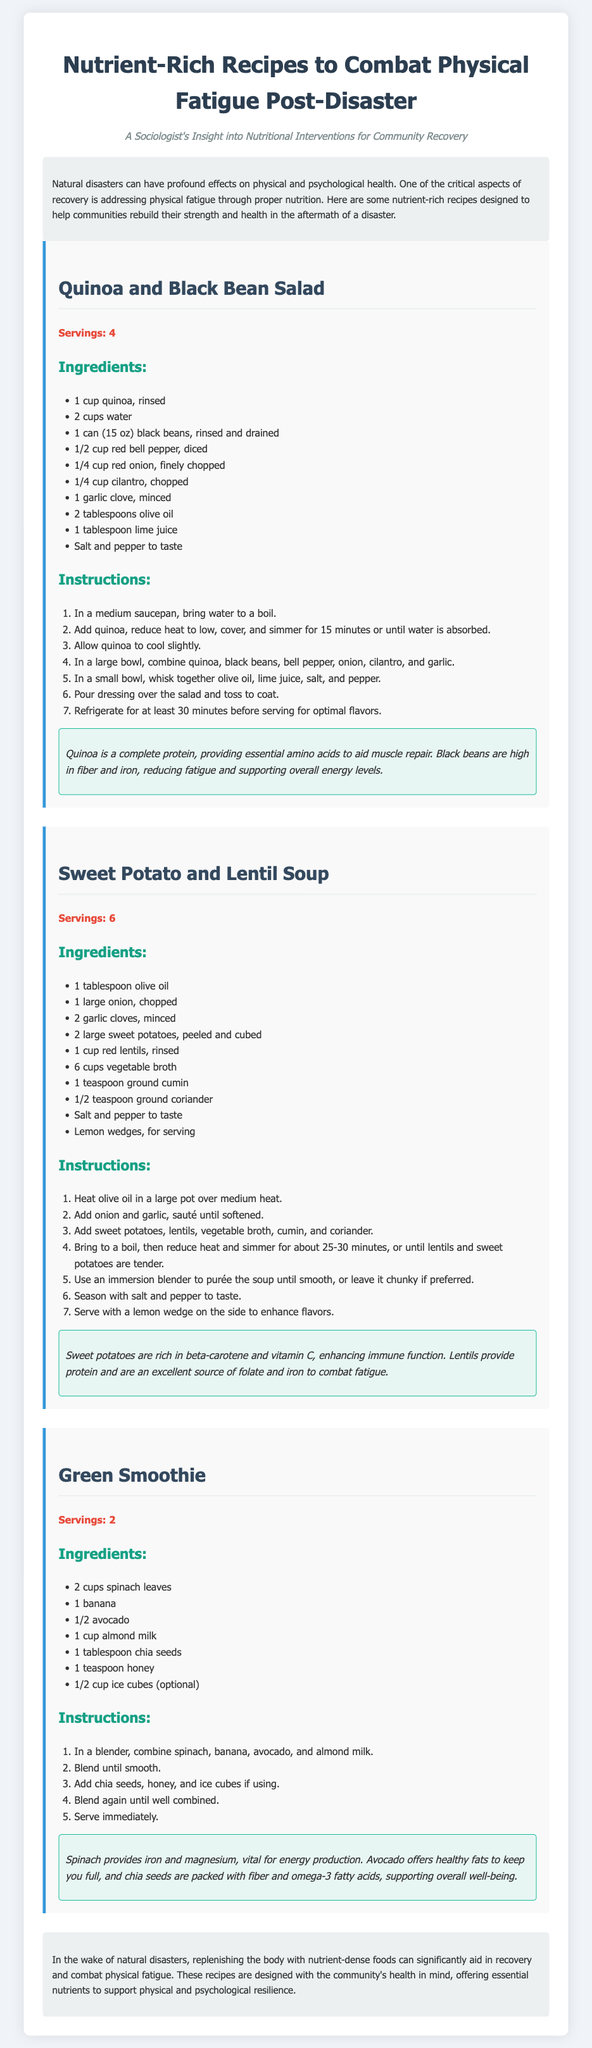what is the title of the document? The title of the document is prominently displayed at the top.
Answer: Nutrient-Rich Recipes to Combat Physical Fatigue Post-Disaster how many servings does the Quinoa and Black Bean Salad recipe yield? The number of servings is listed under the recipe title.
Answer: 4 what primary ingredient is used in the Green Smoothie? The primary ingredients are listed in the recipe's ingredient section.
Answer: spinach leaves what are the two main health benefits of Sweet Potatoes mentioned in the document? The health benefits are outlined in the nutritional benefits section of the soup recipe.
Answer: beta-carotene and vitamin C how long should the Quinoa and Black Bean Salad be refrigerated before serving? The recommended time is stated in the salad recipe instructions.
Answer: 30 minutes which recipe includes lentils as an ingredient? The recipes are clearly defined with their respective ingredients listed.
Answer: Sweet Potato and Lentil Soup how many cups of water are needed for the Quinoa and Black Bean Salad? The amount of water is specified in the ingredients list.
Answer: 2 cups what cooking method is suggested for the Sweet Potato and Lentil Soup? The method of cooking is described in the instructions for that recipe.
Answer: simmer what is the main purpose of the document? The main purpose is indicated in the introduction section.
Answer: address physical fatigue through proper nutrition 